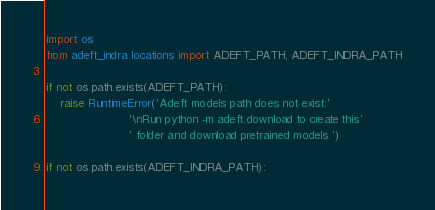Convert code to text. <code><loc_0><loc_0><loc_500><loc_500><_Python_>import os
from adeft_indra.locations import ADEFT_PATH, ADEFT_INDRA_PATH

if not os.path.exists(ADEFT_PATH):
    raise RuntimeError('Adeft models path does not exist:'
                       '\nRun python -m adeft.download to create this'
                       ' folder and download pretrained models.')

if not os.path.exists(ADEFT_INDRA_PATH):</code> 